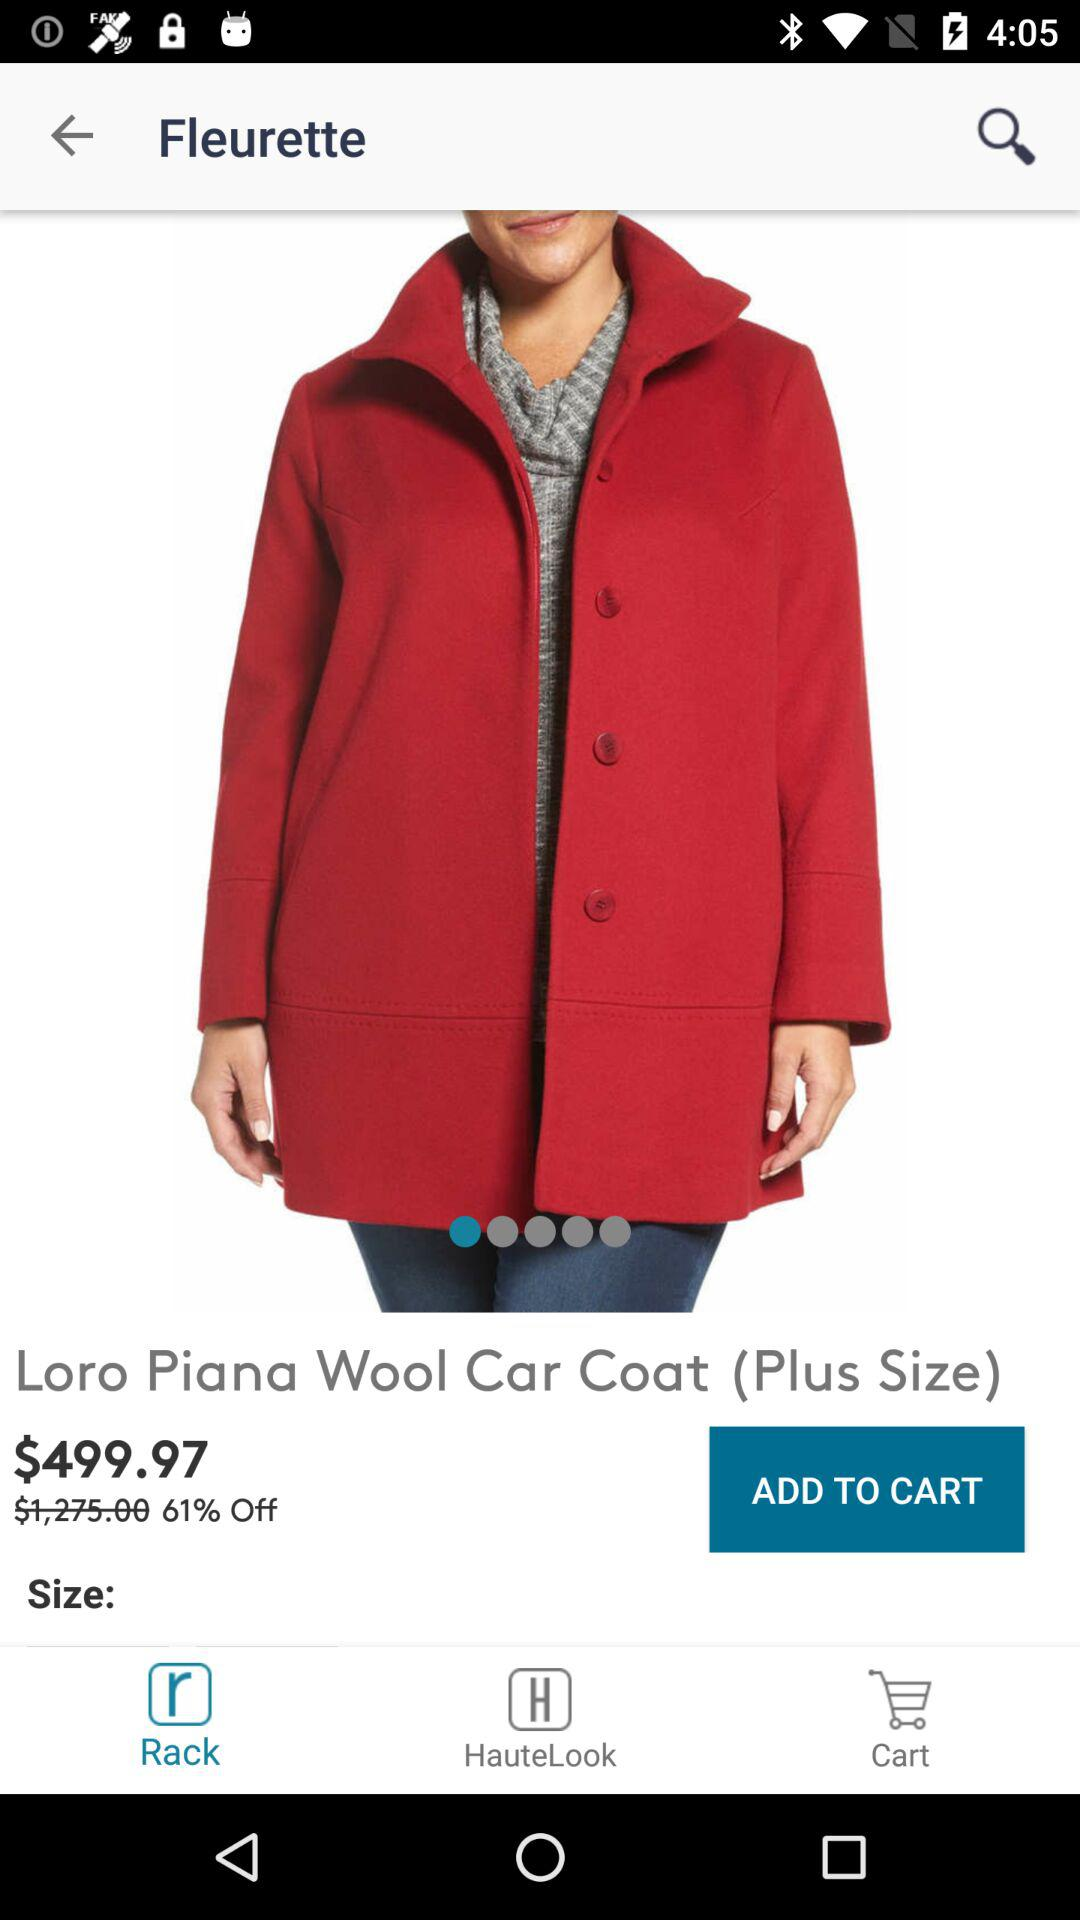What is the actual price of the product? The actual price is $1,275. 